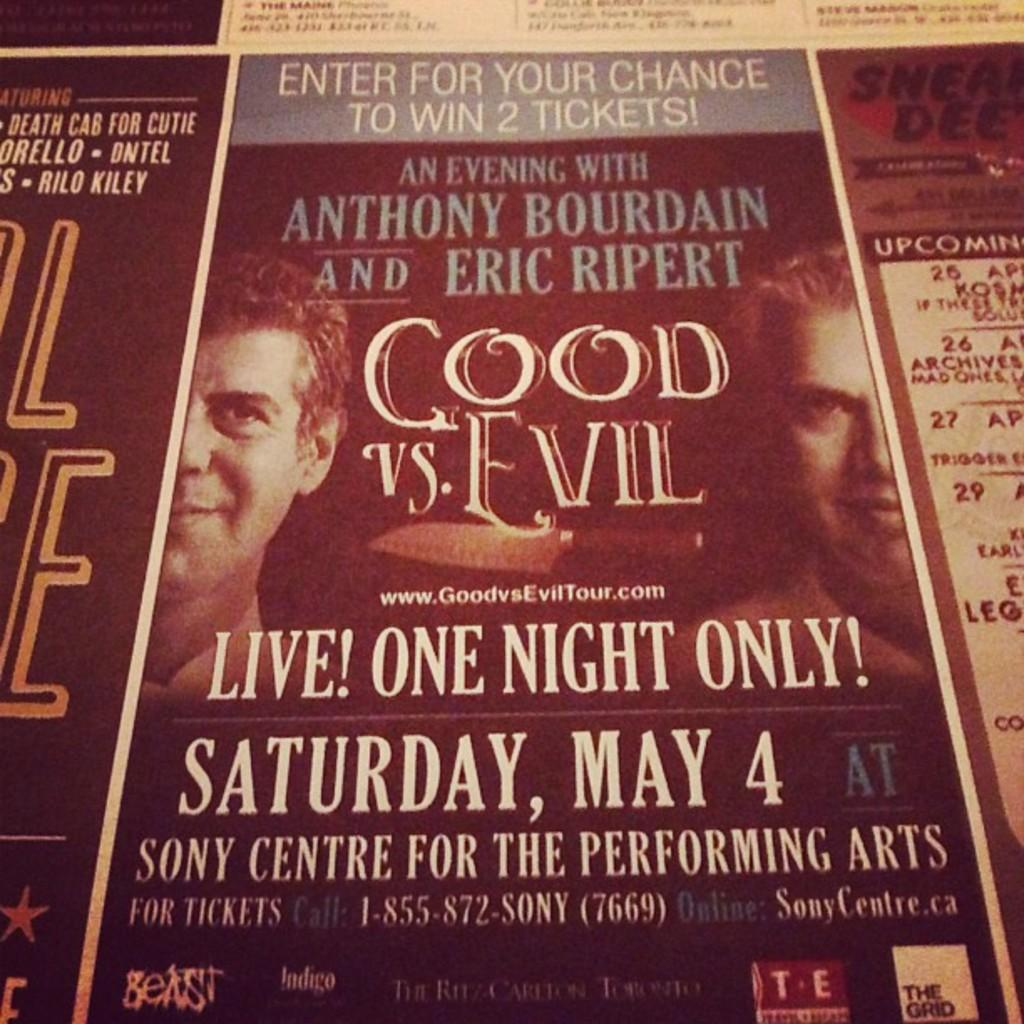<image>
Give a short and clear explanation of the subsequent image. a poster for Good Vs Evil an evening with Anthony Bourdain and Eric Ripert 